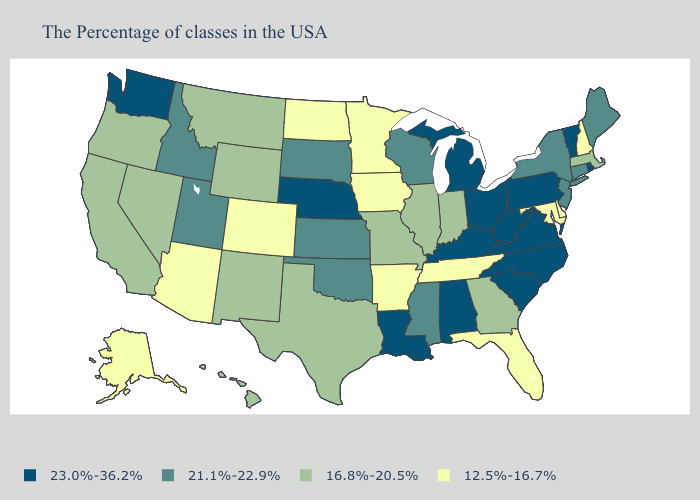Name the states that have a value in the range 23.0%-36.2%?
Keep it brief. Rhode Island, Vermont, Pennsylvania, Virginia, North Carolina, South Carolina, West Virginia, Ohio, Michigan, Kentucky, Alabama, Louisiana, Nebraska, Washington. Name the states that have a value in the range 23.0%-36.2%?
Keep it brief. Rhode Island, Vermont, Pennsylvania, Virginia, North Carolina, South Carolina, West Virginia, Ohio, Michigan, Kentucky, Alabama, Louisiana, Nebraska, Washington. Name the states that have a value in the range 16.8%-20.5%?
Be succinct. Massachusetts, Georgia, Indiana, Illinois, Missouri, Texas, Wyoming, New Mexico, Montana, Nevada, California, Oregon, Hawaii. Name the states that have a value in the range 12.5%-16.7%?
Write a very short answer. New Hampshire, Delaware, Maryland, Florida, Tennessee, Arkansas, Minnesota, Iowa, North Dakota, Colorado, Arizona, Alaska. Name the states that have a value in the range 23.0%-36.2%?
Short answer required. Rhode Island, Vermont, Pennsylvania, Virginia, North Carolina, South Carolina, West Virginia, Ohio, Michigan, Kentucky, Alabama, Louisiana, Nebraska, Washington. Name the states that have a value in the range 21.1%-22.9%?
Keep it brief. Maine, Connecticut, New York, New Jersey, Wisconsin, Mississippi, Kansas, Oklahoma, South Dakota, Utah, Idaho. What is the value of Minnesota?
Short answer required. 12.5%-16.7%. Does the first symbol in the legend represent the smallest category?
Quick response, please. No. Does Alaska have the same value as Tennessee?
Answer briefly. Yes. Among the states that border West Virginia , which have the lowest value?
Give a very brief answer. Maryland. Name the states that have a value in the range 16.8%-20.5%?
Quick response, please. Massachusetts, Georgia, Indiana, Illinois, Missouri, Texas, Wyoming, New Mexico, Montana, Nevada, California, Oregon, Hawaii. What is the value of Alaska?
Concise answer only. 12.5%-16.7%. Name the states that have a value in the range 21.1%-22.9%?
Short answer required. Maine, Connecticut, New York, New Jersey, Wisconsin, Mississippi, Kansas, Oklahoma, South Dakota, Utah, Idaho. What is the value of Tennessee?
Give a very brief answer. 12.5%-16.7%. What is the value of Alabama?
Answer briefly. 23.0%-36.2%. 